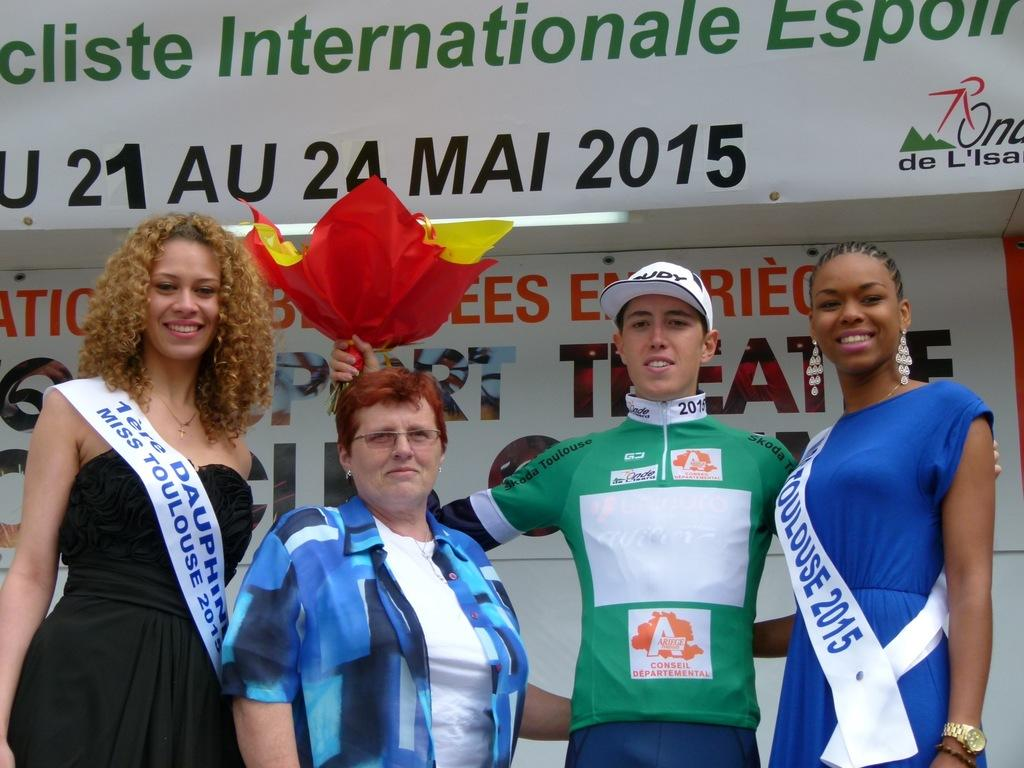<image>
Summarize the visual content of the image. Winning athletic posing for camera at an International event. 